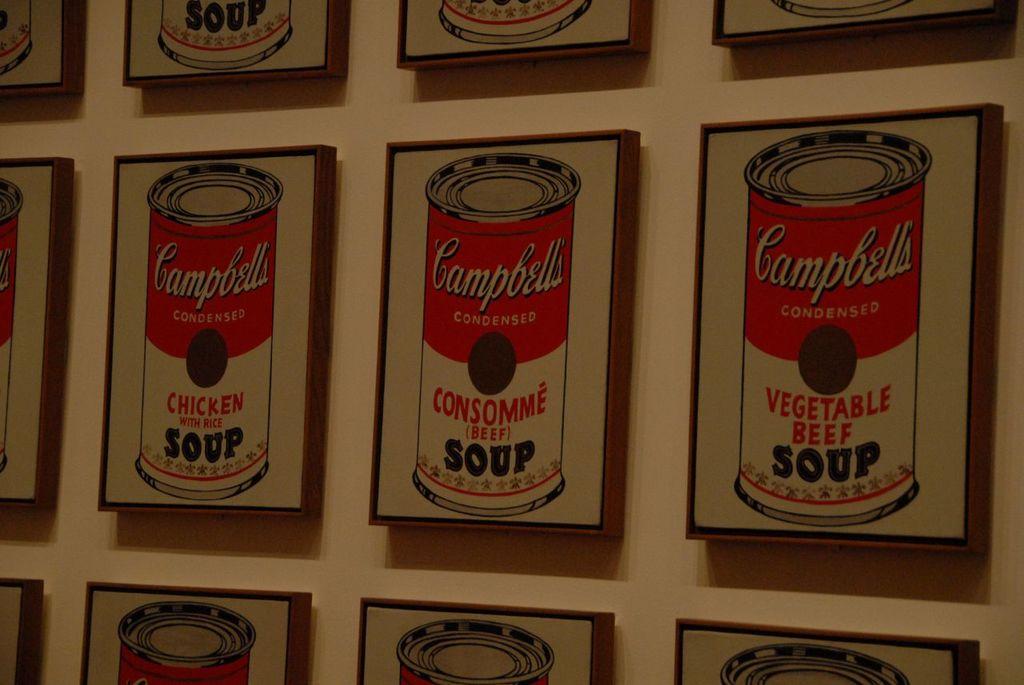Which of these soups is associated with being sick?
Your answer should be very brief. Chicken soup. 